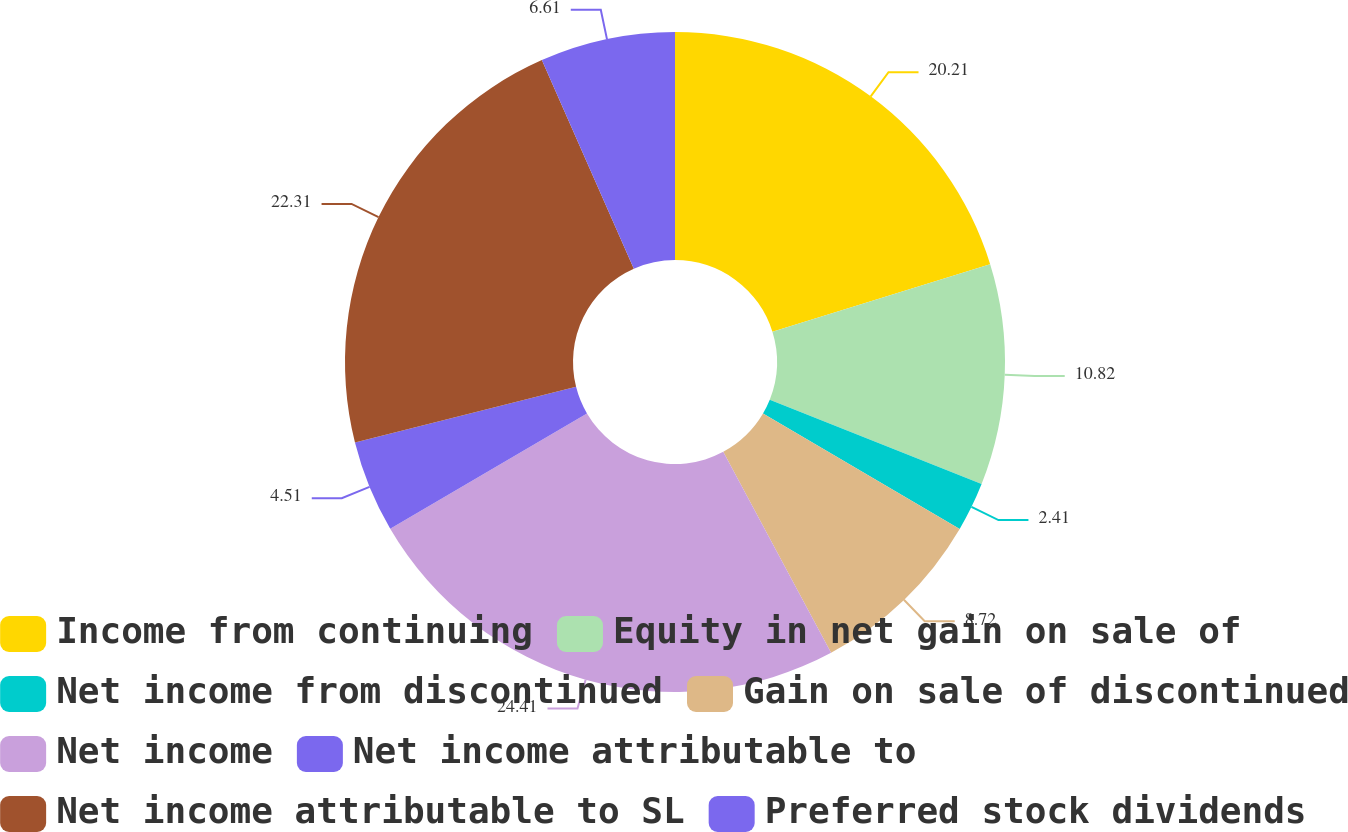<chart> <loc_0><loc_0><loc_500><loc_500><pie_chart><fcel>Income from continuing<fcel>Equity in net gain on sale of<fcel>Net income from discontinued<fcel>Gain on sale of discontinued<fcel>Net income<fcel>Net income attributable to<fcel>Net income attributable to SL<fcel>Preferred stock dividends<nl><fcel>20.21%<fcel>10.82%<fcel>2.41%<fcel>8.72%<fcel>24.41%<fcel>4.51%<fcel>22.31%<fcel>6.61%<nl></chart> 